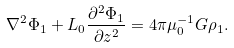Convert formula to latex. <formula><loc_0><loc_0><loc_500><loc_500>\nabla ^ { 2 } \Phi _ { 1 } + L _ { 0 } \frac { \partial ^ { 2 } \Phi _ { 1 } } { \partial z ^ { 2 } } = 4 \pi \mu _ { 0 } ^ { - 1 } G \rho _ { 1 } .</formula> 